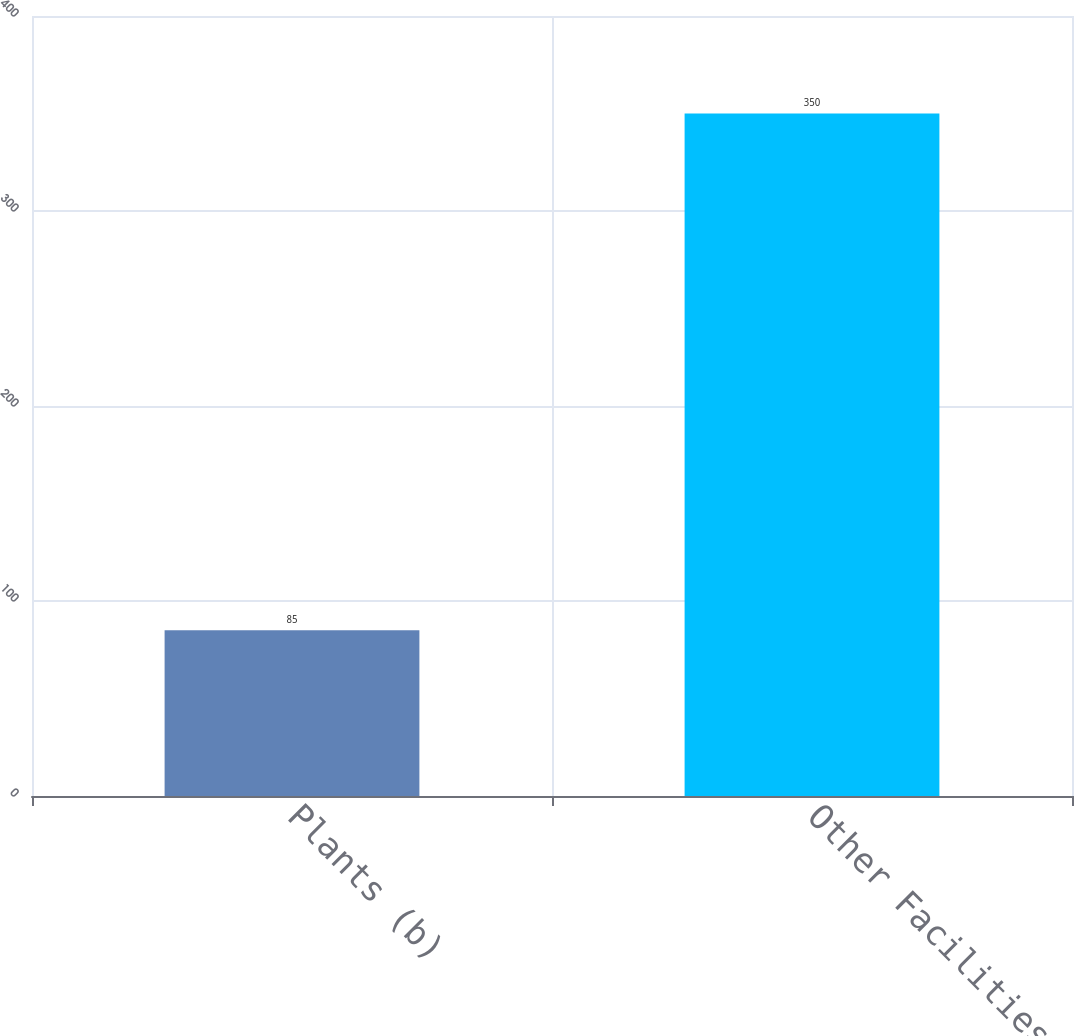<chart> <loc_0><loc_0><loc_500><loc_500><bar_chart><fcel>Plants (b)<fcel>Other Facilities (c)<nl><fcel>85<fcel>350<nl></chart> 